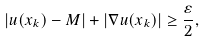Convert formula to latex. <formula><loc_0><loc_0><loc_500><loc_500>| u ( x _ { k } ) - M | + | \nabla u ( x _ { k } ) | \geq \frac { \varepsilon } { 2 } ,</formula> 